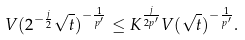<formula> <loc_0><loc_0><loc_500><loc_500>V ( 2 ^ { - \frac { j } { 2 } } \sqrt { t } ) ^ { - \frac { 1 } { p ^ { \prime } } } \leq K ^ { \frac { j } { 2 p ^ { \prime } } } V ( \sqrt { t } ) ^ { - \frac { 1 } { p ^ { \prime } } } .</formula> 